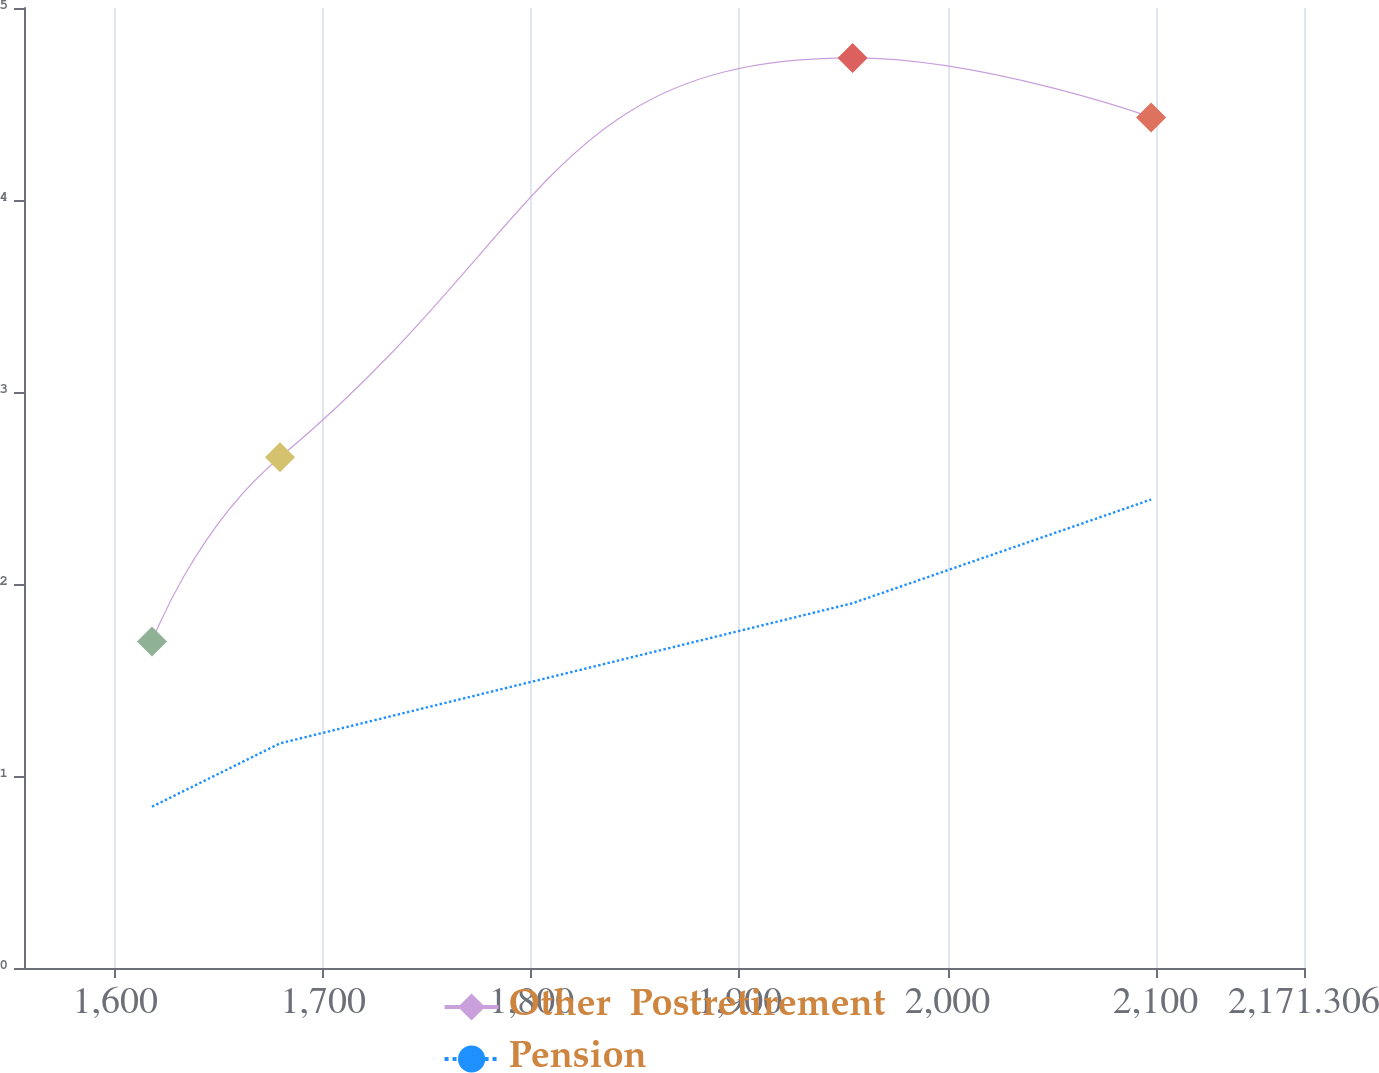Convert chart to OTSL. <chart><loc_0><loc_0><loc_500><loc_500><line_chart><ecel><fcel>Other  Postretirement<fcel>Pension<nl><fcel>1617.68<fcel>1.7<fcel>0.84<nl><fcel>1679.19<fcel>2.66<fcel>1.17<nl><fcel>1954.39<fcel>4.74<fcel>1.9<nl><fcel>2097.85<fcel>4.43<fcel>2.44<nl><fcel>2232.82<fcel>5.05<fcel>2.29<nl></chart> 